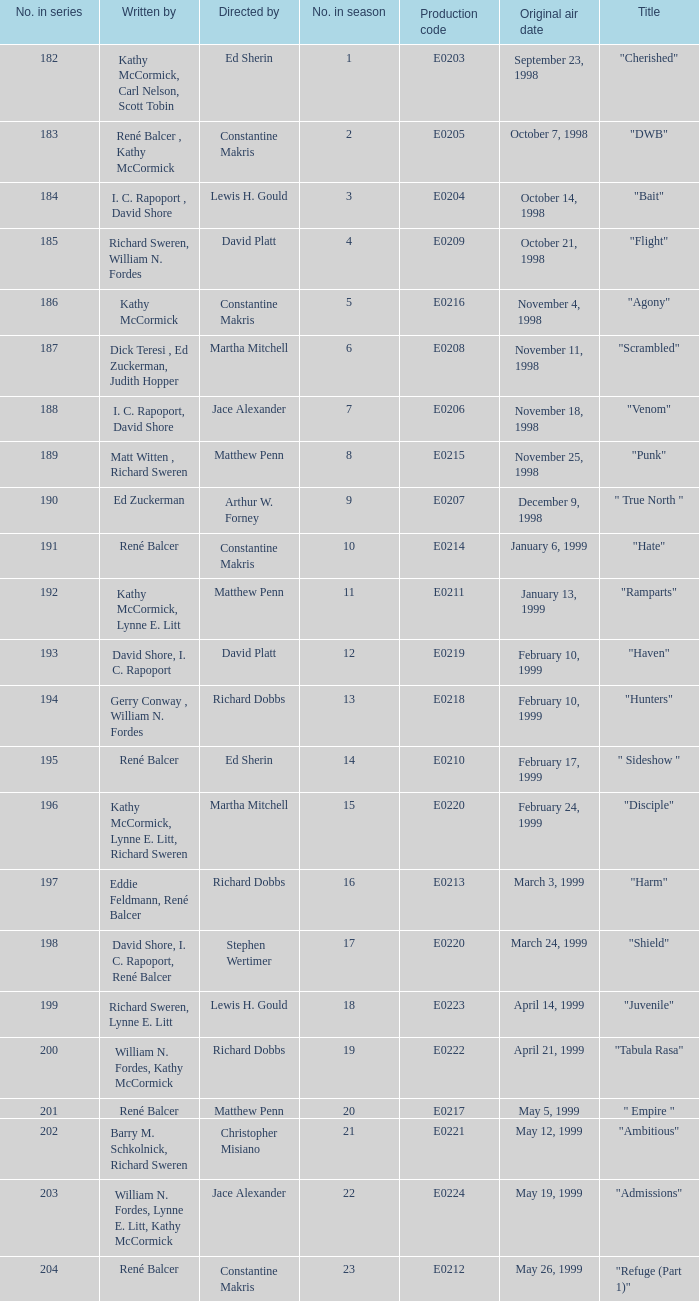What is the season numeral of the episode penned by matt witten, richard sweren? 8.0. 